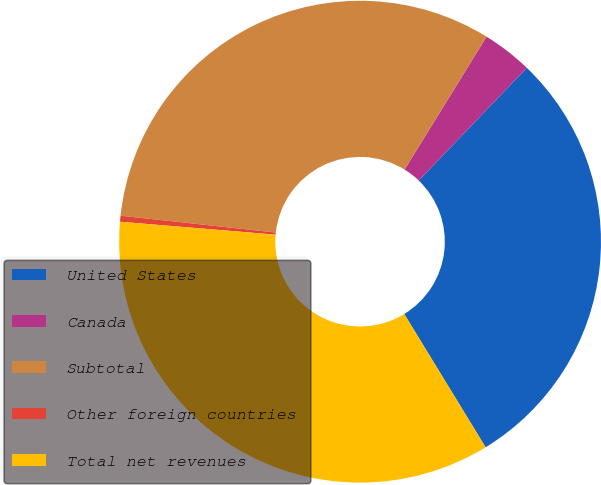Convert chart. <chart><loc_0><loc_0><loc_500><loc_500><pie_chart><fcel>United States<fcel>Canada<fcel>Subtotal<fcel>Other foreign countries<fcel>Total net revenues<nl><fcel>29.1%<fcel>3.37%<fcel>32.07%<fcel>0.4%<fcel>35.04%<nl></chart> 